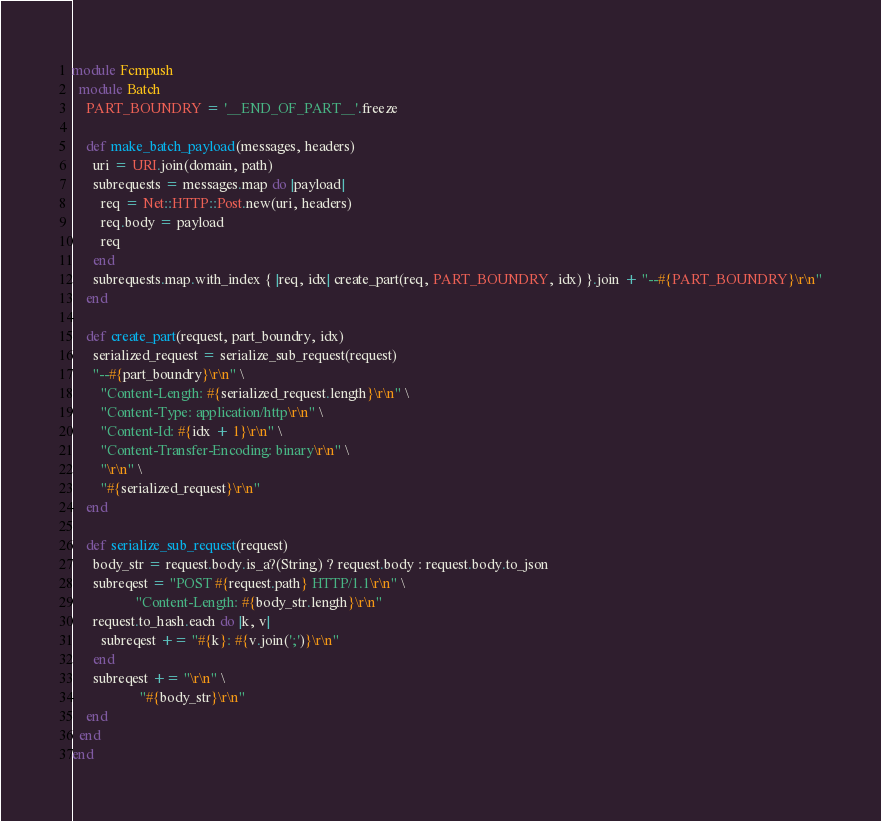Convert code to text. <code><loc_0><loc_0><loc_500><loc_500><_Ruby_>module Fcmpush
  module Batch
    PART_BOUNDRY = '__END_OF_PART__'.freeze

    def make_batch_payload(messages, headers)
      uri = URI.join(domain, path)
      subrequests = messages.map do |payload|
        req = Net::HTTP::Post.new(uri, headers)
        req.body = payload
        req
      end
      subrequests.map.with_index { |req, idx| create_part(req, PART_BOUNDRY, idx) }.join + "--#{PART_BOUNDRY}\r\n"
    end

    def create_part(request, part_boundry, idx)
      serialized_request = serialize_sub_request(request)
      "--#{part_boundry}\r\n" \
        "Content-Length: #{serialized_request.length}\r\n" \
        "Content-Type: application/http\r\n" \
        "Content-Id: #{idx + 1}\r\n" \
        "Content-Transfer-Encoding: binary\r\n" \
        "\r\n" \
        "#{serialized_request}\r\n"
    end

    def serialize_sub_request(request)
      body_str = request.body.is_a?(String) ? request.body : request.body.to_json
      subreqest = "POST #{request.path} HTTP/1.1\r\n" \
                  "Content-Length: #{body_str.length}\r\n"
      request.to_hash.each do |k, v|
        subreqest += "#{k}: #{v.join(';')}\r\n"
      end
      subreqest += "\r\n" \
                   "#{body_str}\r\n"
    end
  end
end
</code> 